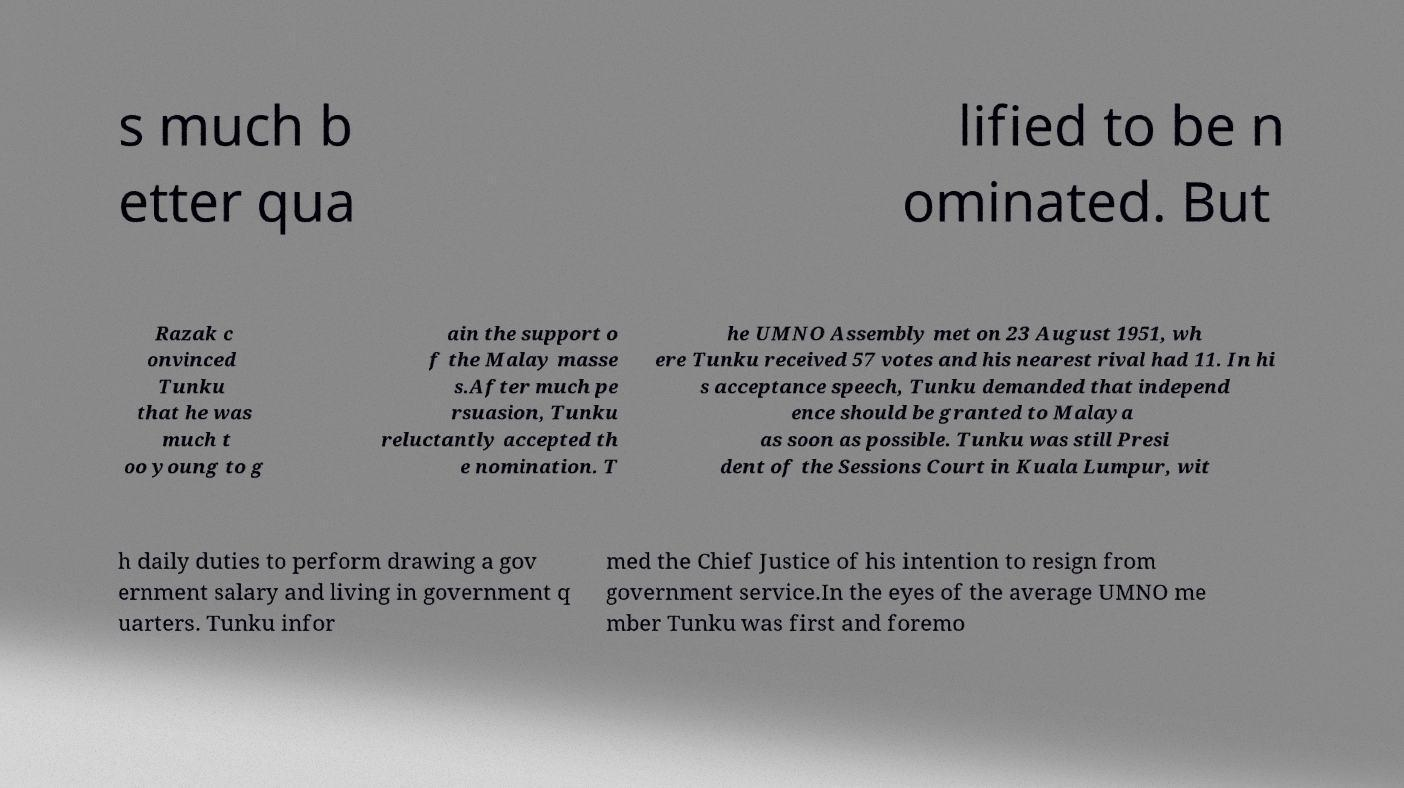Can you read and provide the text displayed in the image?This photo seems to have some interesting text. Can you extract and type it out for me? s much b etter qua lified to be n ominated. But Razak c onvinced Tunku that he was much t oo young to g ain the support o f the Malay masse s.After much pe rsuasion, Tunku reluctantly accepted th e nomination. T he UMNO Assembly met on 23 August 1951, wh ere Tunku received 57 votes and his nearest rival had 11. In hi s acceptance speech, Tunku demanded that independ ence should be granted to Malaya as soon as possible. Tunku was still Presi dent of the Sessions Court in Kuala Lumpur, wit h daily duties to perform drawing a gov ernment salary and living in government q uarters. Tunku infor med the Chief Justice of his intention to resign from government service.In the eyes of the average UMNO me mber Tunku was first and foremo 